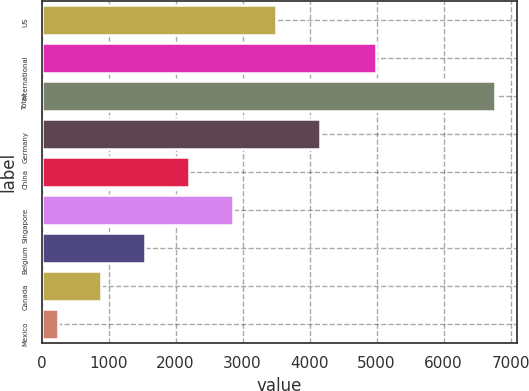Convert chart to OTSL. <chart><loc_0><loc_0><loc_500><loc_500><bar_chart><fcel>US<fcel>International<fcel>Total<fcel>Germany<fcel>China<fcel>Singapore<fcel>Belgium<fcel>Canada<fcel>Mexico<nl><fcel>3502<fcel>4991<fcel>6763<fcel>4154.2<fcel>2197.6<fcel>2849.8<fcel>1545.4<fcel>893.2<fcel>241<nl></chart> 